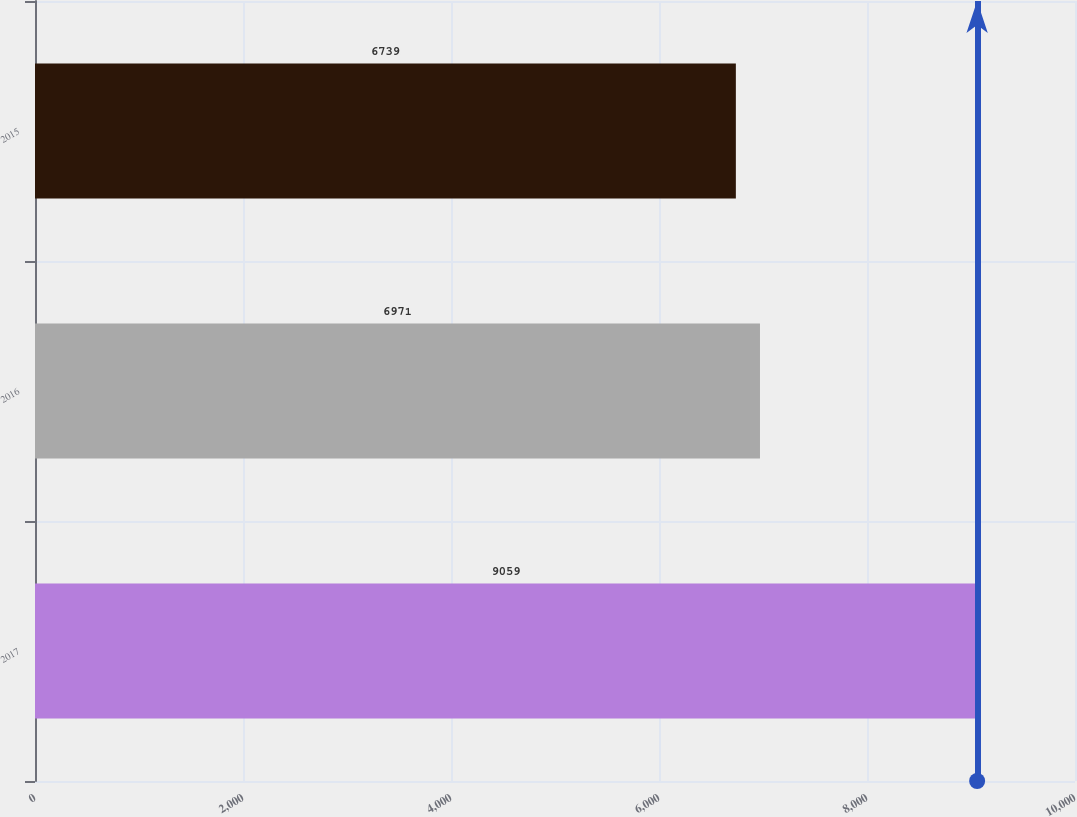Convert chart to OTSL. <chart><loc_0><loc_0><loc_500><loc_500><bar_chart><fcel>2017<fcel>2016<fcel>2015<nl><fcel>9059<fcel>6971<fcel>6739<nl></chart> 